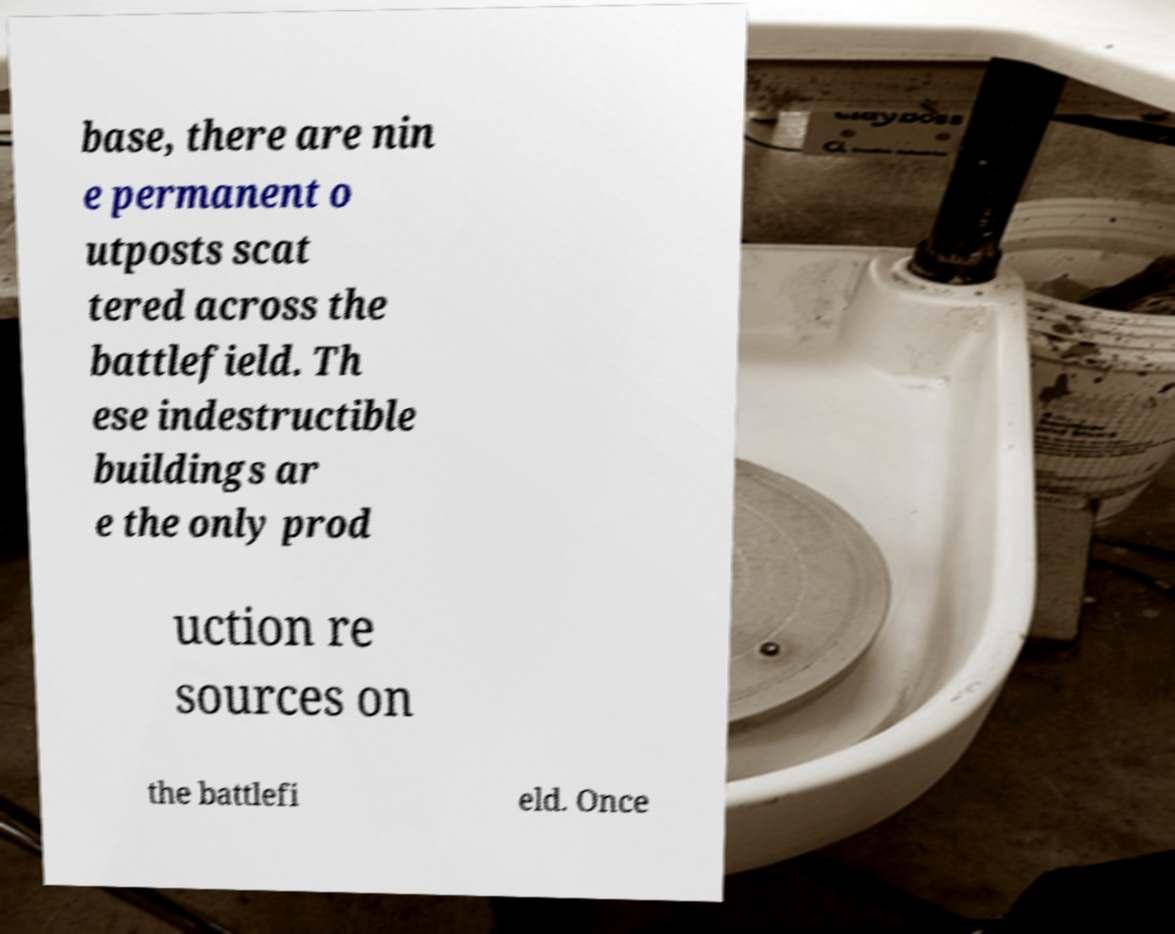Please identify and transcribe the text found in this image. base, there are nin e permanent o utposts scat tered across the battlefield. Th ese indestructible buildings ar e the only prod uction re sources on the battlefi eld. Once 